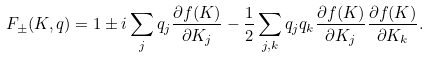<formula> <loc_0><loc_0><loc_500><loc_500>F _ { \pm } ( K , q ) = 1 \pm i \sum _ { j } q _ { j } \frac { \partial f ( K ) } { \partial K _ { j } } - \frac { 1 } { 2 } \sum _ { j , k } q _ { j } q _ { k } \frac { \partial f ( K ) } { \partial K _ { j } } \frac { \partial f ( K ) } { \partial K _ { k } } .</formula> 